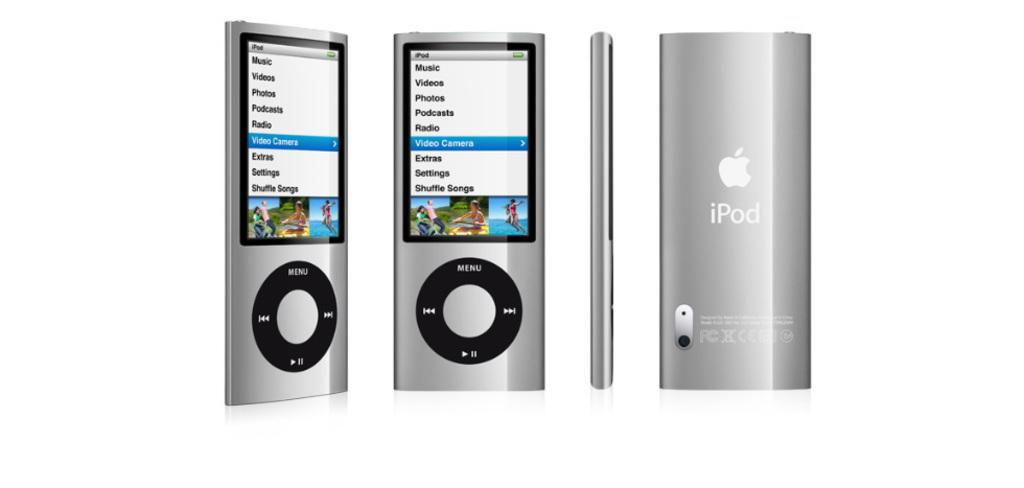<image>
Write a terse but informative summary of the picture. Four different ipods with a silver paitjob showing the device from different angles. 